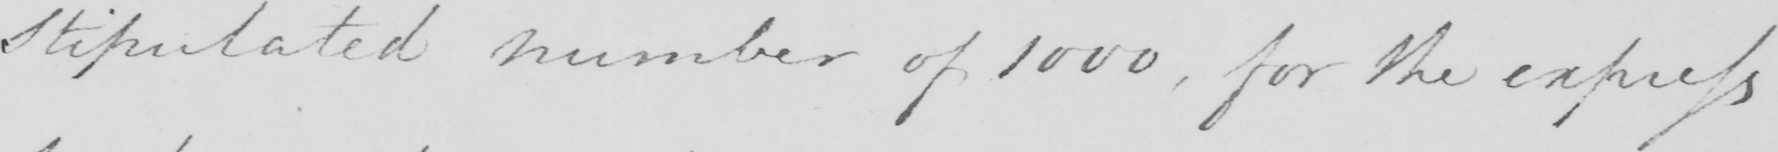What text is written in this handwritten line? Stipulated number of 1000 , for the express 